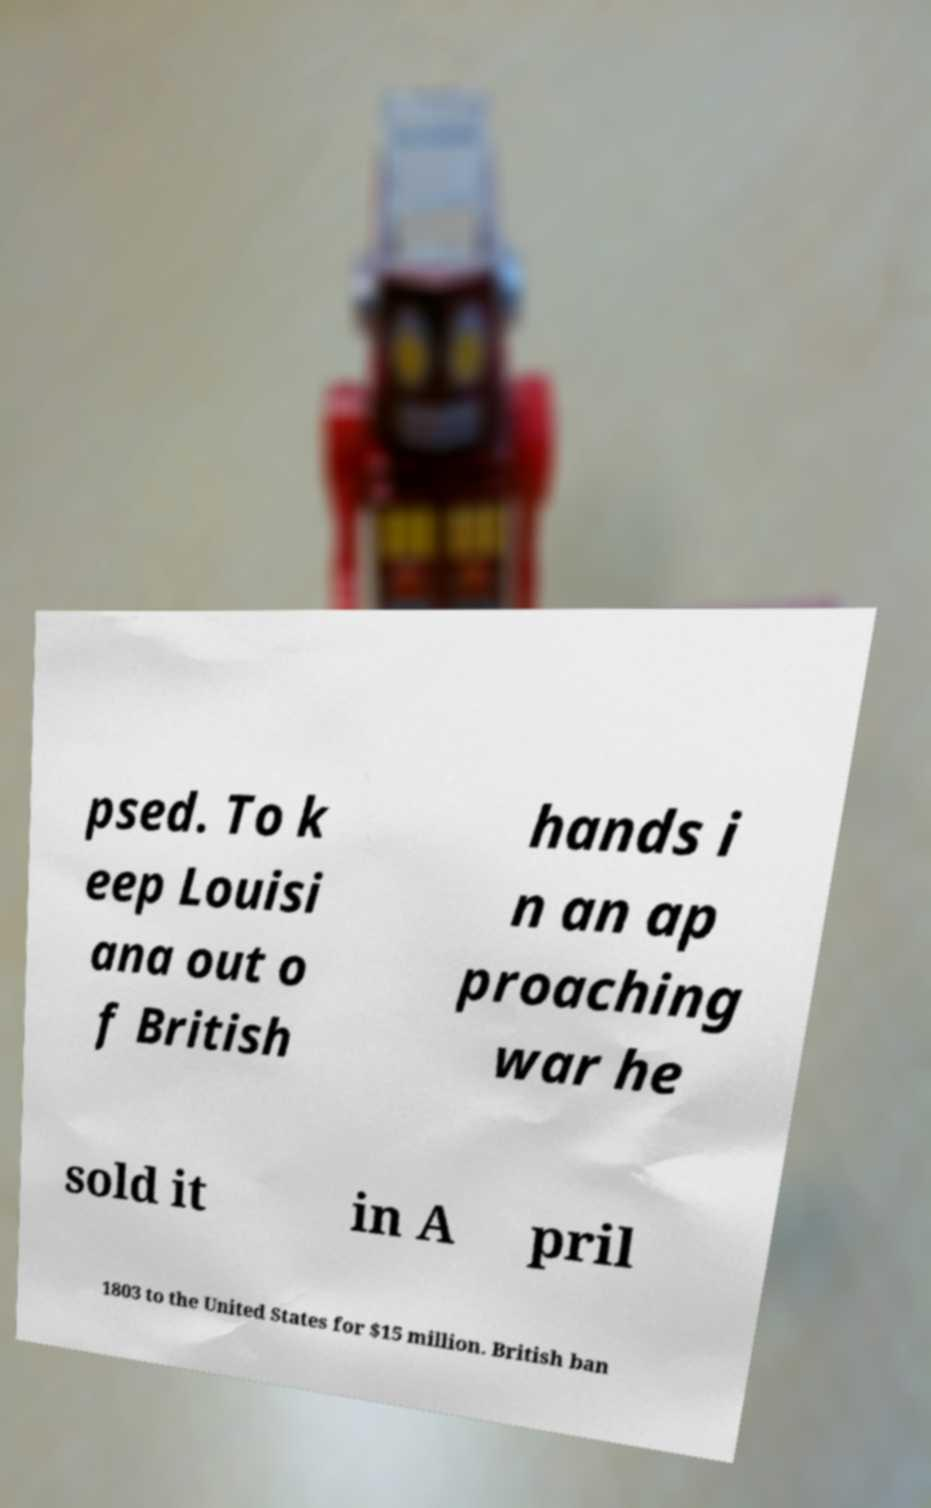Could you extract and type out the text from this image? psed. To k eep Louisi ana out o f British hands i n an ap proaching war he sold it in A pril 1803 to the United States for $15 million. British ban 